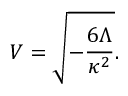<formula> <loc_0><loc_0><loc_500><loc_500>V = \sqrt { - \frac { 6 \Lambda } { \kappa ^ { 2 } } } .</formula> 